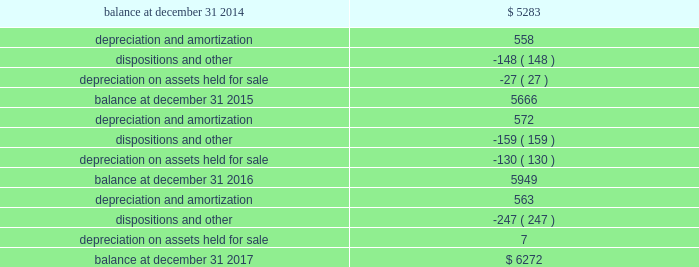Schedule iii page 6 of 6 host hotels & resorts , inc. , and subsidiaries host hotels & resorts , l.p. , and subsidiaries real estate and accumulated depreciation december 31 , 2017 ( in millions ) ( b ) the change in accumulated depreciation and amortization of real estate assets for the fiscal years ended december 31 , 2017 , 2016 and 2015 is as follows: .
( c ) the aggregate cost of real estate for federal income tax purposes is approximately $ 10698 million at december 31 , 2017 .
( d ) the total cost of properties excludes construction-in-progress properties. .
What was the net change in millions in the accumulated depreciation and amortization of real estate assets from 2014 to 2015? 
Computations: (5666 - 5283)
Answer: 383.0. 